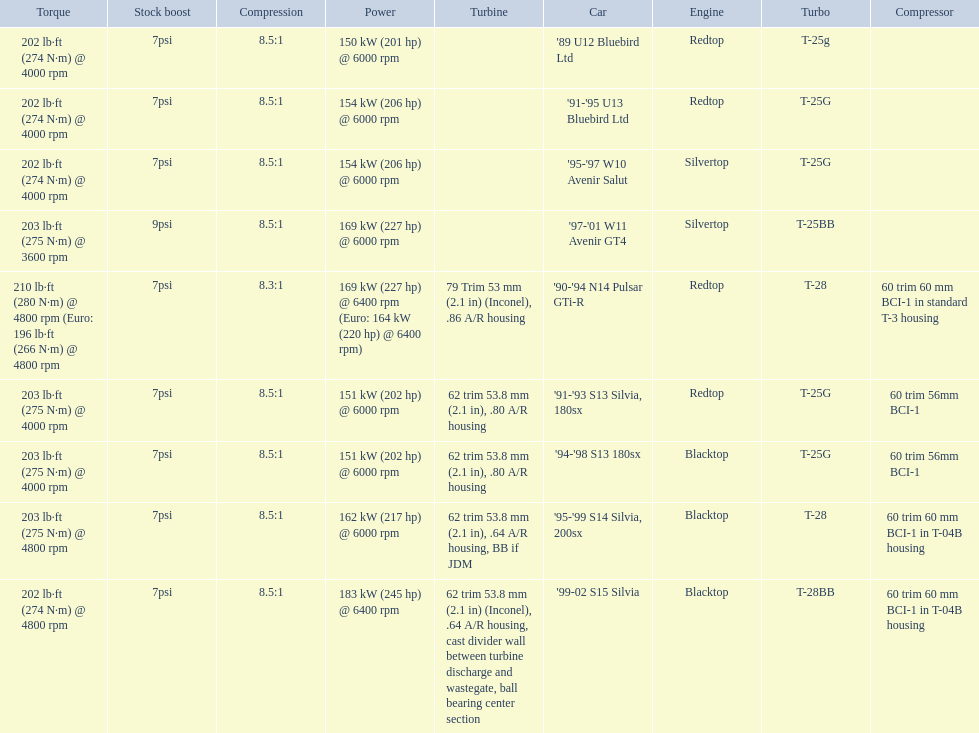What are the listed hp of the cars? 150 kW (201 hp) @ 6000 rpm, 154 kW (206 hp) @ 6000 rpm, 154 kW (206 hp) @ 6000 rpm, 169 kW (227 hp) @ 6000 rpm, 169 kW (227 hp) @ 6400 rpm (Euro: 164 kW (220 hp) @ 6400 rpm), 151 kW (202 hp) @ 6000 rpm, 151 kW (202 hp) @ 6000 rpm, 162 kW (217 hp) @ 6000 rpm, 183 kW (245 hp) @ 6400 rpm. Which is the only car with over 230 hp? '99-02 S15 Silvia. 